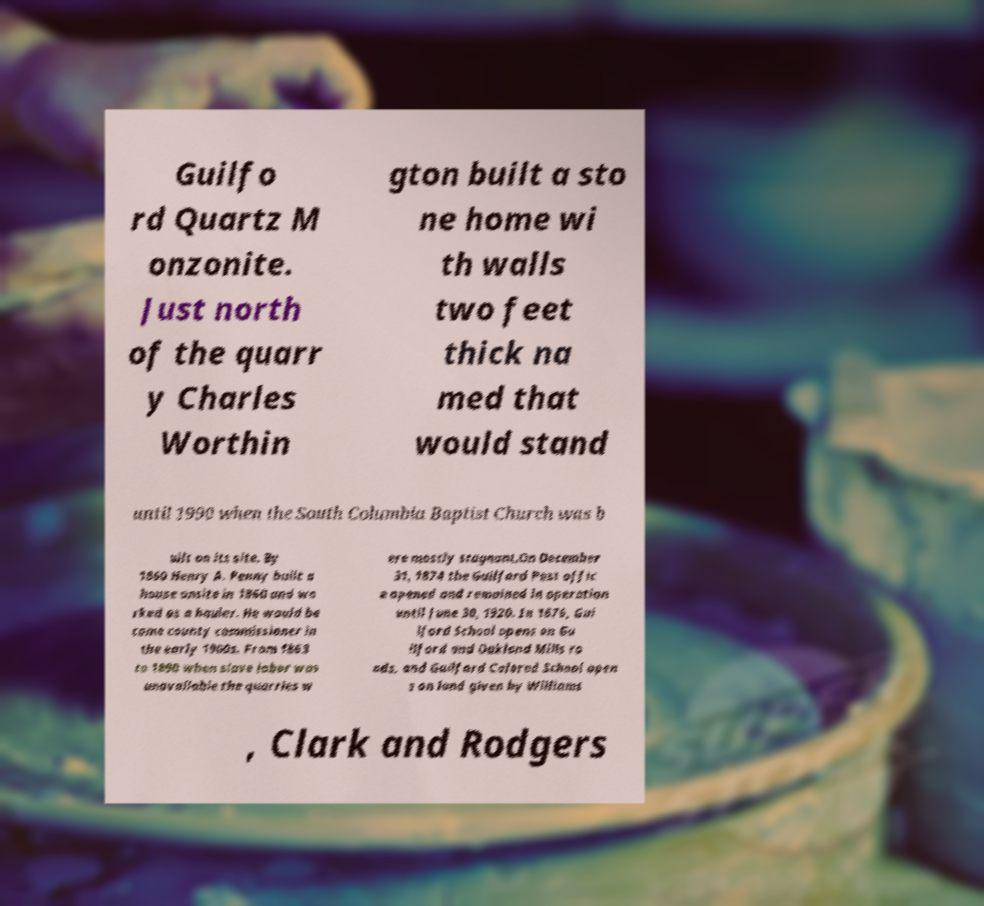Can you read and provide the text displayed in the image?This photo seems to have some interesting text. Can you extract and type it out for me? Guilfo rd Quartz M onzonite. Just north of the quarr y Charles Worthin gton built a sto ne home wi th walls two feet thick na med that would stand until 1990 when the South Columbia Baptist Church was b uilt on its site. By 1860 Henry A. Penny built a house onsite in 1860 and wo rked as a hauler. He would be come county commissioner in the early 1900s. From 1863 to 1890 when slave labor was unavailable the quarries w ere mostly stagnant.On December 31, 1874 the Guilford Post offic e opened and remained in operation until June 30, 1920. In 1876, Gui lford School opens on Gu ilford and Oakland Mills ro ads, and Guilford Colored School open s on land given by Williams , Clark and Rodgers 